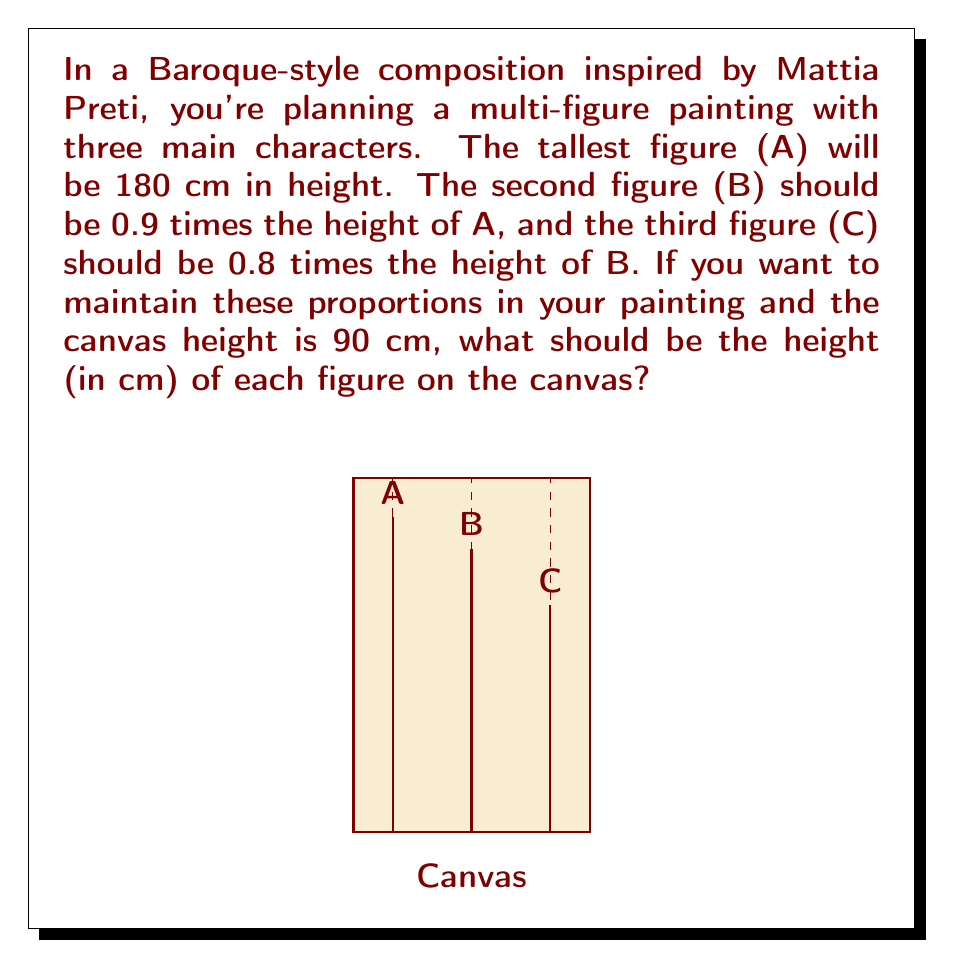Show me your answer to this math problem. Let's approach this step-by-step:

1) First, we need to establish the actual heights of figures B and C:
   
   Height of B = $0.9 \times 180$ cm $= 162$ cm
   Height of C = $0.8 \times 162$ cm $= 129.6$ cm

2) Now, we need to determine the scale factor. The scale factor is the ratio of the canvas height to the height of the tallest figure:

   Scale factor = $\frac{\text{Canvas height}}{\text{Height of tallest figure}} = \frac{90 \text{ cm}}{180 \text{ cm}} = 0.5$

3) To find the height of each figure on the canvas, we multiply their actual heights by the scale factor:

   Figure A on canvas: $180 \text{ cm} \times 0.5 = 90$ cm
   Figure B on canvas: $162 \text{ cm} \times 0.5 = 81$ cm
   Figure C on canvas: $129.6 \text{ cm} \times 0.5 = 64.8$ cm

Therefore, on the 90 cm tall canvas:
- Figure A should be 90 cm tall
- Figure B should be 81 cm tall
- Figure C should be 64.8 cm tall
Answer: A: 90 cm, B: 81 cm, C: 64.8 cm 